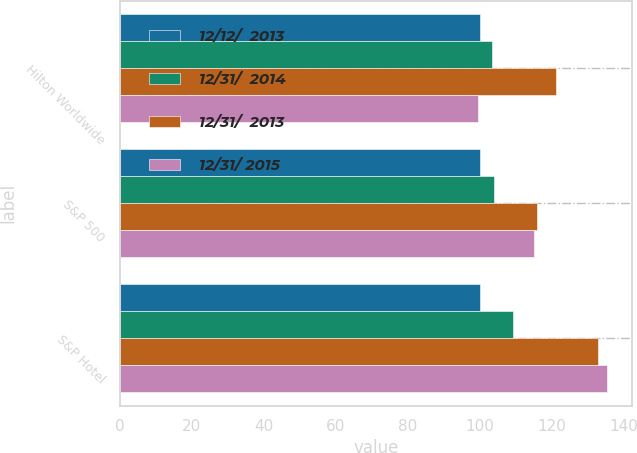Convert chart. <chart><loc_0><loc_0><loc_500><loc_500><stacked_bar_chart><ecel><fcel>Hilton Worldwide<fcel>S&P 500<fcel>S&P Hotel<nl><fcel>12/12/  2013<fcel>100<fcel>100<fcel>100<nl><fcel>12/31/  2014<fcel>103.5<fcel>104.1<fcel>109.2<nl><fcel>12/31/  2013<fcel>121.3<fcel>116<fcel>132.8<nl><fcel>12/31/ 2015<fcel>99.5<fcel>115.1<fcel>135.5<nl></chart> 